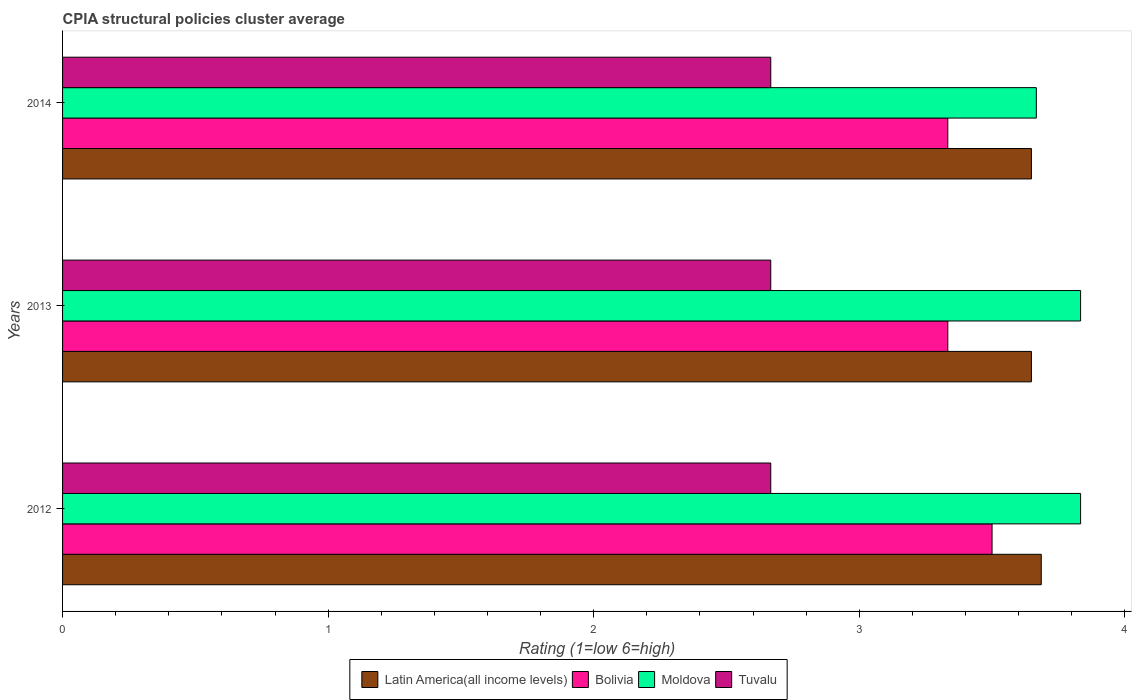How many different coloured bars are there?
Provide a short and direct response. 4. How many bars are there on the 3rd tick from the bottom?
Provide a succinct answer. 4. What is the label of the 2nd group of bars from the top?
Provide a succinct answer. 2013. In how many cases, is the number of bars for a given year not equal to the number of legend labels?
Your answer should be very brief. 0. What is the CPIA rating in Moldova in 2014?
Make the answer very short. 3.67. Across all years, what is the maximum CPIA rating in Moldova?
Make the answer very short. 3.83. Across all years, what is the minimum CPIA rating in Latin America(all income levels)?
Your answer should be very brief. 3.65. In which year was the CPIA rating in Latin America(all income levels) maximum?
Give a very brief answer. 2012. What is the total CPIA rating in Bolivia in the graph?
Ensure brevity in your answer.  10.17. What is the difference between the CPIA rating in Moldova in 2012 and that in 2014?
Provide a succinct answer. 0.17. What is the difference between the CPIA rating in Moldova in 2013 and the CPIA rating in Tuvalu in 2012?
Provide a succinct answer. 1.17. What is the average CPIA rating in Bolivia per year?
Make the answer very short. 3.39. In the year 2012, what is the difference between the CPIA rating in Tuvalu and CPIA rating in Bolivia?
Offer a very short reply. -0.83. In how many years, is the CPIA rating in Moldova greater than 2.6 ?
Offer a terse response. 3. What is the ratio of the CPIA rating in Moldova in 2013 to that in 2014?
Ensure brevity in your answer.  1.05. Is the CPIA rating in Bolivia in 2013 less than that in 2014?
Your answer should be compact. No. What is the difference between the highest and the lowest CPIA rating in Latin America(all income levels)?
Give a very brief answer. 0.04. In how many years, is the CPIA rating in Moldova greater than the average CPIA rating in Moldova taken over all years?
Your response must be concise. 2. Is it the case that in every year, the sum of the CPIA rating in Latin America(all income levels) and CPIA rating in Tuvalu is greater than the sum of CPIA rating in Moldova and CPIA rating in Bolivia?
Ensure brevity in your answer.  No. What does the 2nd bar from the top in 2014 represents?
Give a very brief answer. Moldova. What does the 2nd bar from the bottom in 2014 represents?
Keep it short and to the point. Bolivia. How many bars are there?
Offer a terse response. 12. Are all the bars in the graph horizontal?
Keep it short and to the point. Yes. How many years are there in the graph?
Provide a short and direct response. 3. What is the difference between two consecutive major ticks on the X-axis?
Give a very brief answer. 1. Are the values on the major ticks of X-axis written in scientific E-notation?
Provide a succinct answer. No. Where does the legend appear in the graph?
Your answer should be compact. Bottom center. How are the legend labels stacked?
Give a very brief answer. Horizontal. What is the title of the graph?
Make the answer very short. CPIA structural policies cluster average. What is the label or title of the Y-axis?
Provide a short and direct response. Years. What is the Rating (1=low 6=high) in Latin America(all income levels) in 2012?
Offer a terse response. 3.69. What is the Rating (1=low 6=high) in Moldova in 2012?
Your answer should be very brief. 3.83. What is the Rating (1=low 6=high) in Tuvalu in 2012?
Offer a terse response. 2.67. What is the Rating (1=low 6=high) in Latin America(all income levels) in 2013?
Your response must be concise. 3.65. What is the Rating (1=low 6=high) of Bolivia in 2013?
Offer a terse response. 3.33. What is the Rating (1=low 6=high) of Moldova in 2013?
Provide a short and direct response. 3.83. What is the Rating (1=low 6=high) in Tuvalu in 2013?
Keep it short and to the point. 2.67. What is the Rating (1=low 6=high) in Latin America(all income levels) in 2014?
Provide a succinct answer. 3.65. What is the Rating (1=low 6=high) in Bolivia in 2014?
Keep it short and to the point. 3.33. What is the Rating (1=low 6=high) of Moldova in 2014?
Your response must be concise. 3.67. What is the Rating (1=low 6=high) of Tuvalu in 2014?
Ensure brevity in your answer.  2.67. Across all years, what is the maximum Rating (1=low 6=high) in Latin America(all income levels)?
Provide a succinct answer. 3.69. Across all years, what is the maximum Rating (1=low 6=high) in Bolivia?
Give a very brief answer. 3.5. Across all years, what is the maximum Rating (1=low 6=high) of Moldova?
Keep it short and to the point. 3.83. Across all years, what is the maximum Rating (1=low 6=high) of Tuvalu?
Offer a very short reply. 2.67. Across all years, what is the minimum Rating (1=low 6=high) in Latin America(all income levels)?
Keep it short and to the point. 3.65. Across all years, what is the minimum Rating (1=low 6=high) in Bolivia?
Your answer should be compact. 3.33. Across all years, what is the minimum Rating (1=low 6=high) of Moldova?
Provide a succinct answer. 3.67. Across all years, what is the minimum Rating (1=low 6=high) of Tuvalu?
Ensure brevity in your answer.  2.67. What is the total Rating (1=low 6=high) in Latin America(all income levels) in the graph?
Keep it short and to the point. 10.98. What is the total Rating (1=low 6=high) in Bolivia in the graph?
Offer a terse response. 10.17. What is the total Rating (1=low 6=high) in Moldova in the graph?
Ensure brevity in your answer.  11.33. What is the total Rating (1=low 6=high) of Tuvalu in the graph?
Offer a very short reply. 8. What is the difference between the Rating (1=low 6=high) in Latin America(all income levels) in 2012 and that in 2013?
Provide a succinct answer. 0.04. What is the difference between the Rating (1=low 6=high) in Moldova in 2012 and that in 2013?
Your answer should be very brief. 0. What is the difference between the Rating (1=low 6=high) in Tuvalu in 2012 and that in 2013?
Ensure brevity in your answer.  0. What is the difference between the Rating (1=low 6=high) of Latin America(all income levels) in 2012 and that in 2014?
Offer a very short reply. 0.04. What is the difference between the Rating (1=low 6=high) in Bolivia in 2012 and that in 2014?
Provide a succinct answer. 0.17. What is the difference between the Rating (1=low 6=high) in Moldova in 2012 and that in 2014?
Offer a very short reply. 0.17. What is the difference between the Rating (1=low 6=high) of Tuvalu in 2012 and that in 2014?
Keep it short and to the point. -0. What is the difference between the Rating (1=low 6=high) of Tuvalu in 2013 and that in 2014?
Ensure brevity in your answer.  -0. What is the difference between the Rating (1=low 6=high) of Latin America(all income levels) in 2012 and the Rating (1=low 6=high) of Bolivia in 2013?
Keep it short and to the point. 0.35. What is the difference between the Rating (1=low 6=high) of Latin America(all income levels) in 2012 and the Rating (1=low 6=high) of Moldova in 2013?
Offer a very short reply. -0.15. What is the difference between the Rating (1=low 6=high) in Latin America(all income levels) in 2012 and the Rating (1=low 6=high) in Tuvalu in 2013?
Provide a short and direct response. 1.02. What is the difference between the Rating (1=low 6=high) of Bolivia in 2012 and the Rating (1=low 6=high) of Tuvalu in 2013?
Ensure brevity in your answer.  0.83. What is the difference between the Rating (1=low 6=high) of Latin America(all income levels) in 2012 and the Rating (1=low 6=high) of Bolivia in 2014?
Ensure brevity in your answer.  0.35. What is the difference between the Rating (1=low 6=high) of Latin America(all income levels) in 2012 and the Rating (1=low 6=high) of Moldova in 2014?
Ensure brevity in your answer.  0.02. What is the difference between the Rating (1=low 6=high) of Latin America(all income levels) in 2012 and the Rating (1=low 6=high) of Tuvalu in 2014?
Provide a succinct answer. 1.02. What is the difference between the Rating (1=low 6=high) of Moldova in 2012 and the Rating (1=low 6=high) of Tuvalu in 2014?
Provide a short and direct response. 1.17. What is the difference between the Rating (1=low 6=high) in Latin America(all income levels) in 2013 and the Rating (1=low 6=high) in Bolivia in 2014?
Make the answer very short. 0.31. What is the difference between the Rating (1=low 6=high) of Latin America(all income levels) in 2013 and the Rating (1=low 6=high) of Moldova in 2014?
Offer a terse response. -0.02. What is the difference between the Rating (1=low 6=high) in Latin America(all income levels) in 2013 and the Rating (1=low 6=high) in Tuvalu in 2014?
Your response must be concise. 0.98. What is the average Rating (1=low 6=high) in Latin America(all income levels) per year?
Provide a short and direct response. 3.66. What is the average Rating (1=low 6=high) of Bolivia per year?
Make the answer very short. 3.39. What is the average Rating (1=low 6=high) of Moldova per year?
Ensure brevity in your answer.  3.78. What is the average Rating (1=low 6=high) in Tuvalu per year?
Your answer should be compact. 2.67. In the year 2012, what is the difference between the Rating (1=low 6=high) in Latin America(all income levels) and Rating (1=low 6=high) in Bolivia?
Make the answer very short. 0.19. In the year 2012, what is the difference between the Rating (1=low 6=high) in Latin America(all income levels) and Rating (1=low 6=high) in Moldova?
Ensure brevity in your answer.  -0.15. In the year 2012, what is the difference between the Rating (1=low 6=high) of Latin America(all income levels) and Rating (1=low 6=high) of Tuvalu?
Offer a terse response. 1.02. In the year 2012, what is the difference between the Rating (1=low 6=high) of Bolivia and Rating (1=low 6=high) of Moldova?
Make the answer very short. -0.33. In the year 2012, what is the difference between the Rating (1=low 6=high) in Moldova and Rating (1=low 6=high) in Tuvalu?
Offer a very short reply. 1.17. In the year 2013, what is the difference between the Rating (1=low 6=high) of Latin America(all income levels) and Rating (1=low 6=high) of Bolivia?
Make the answer very short. 0.31. In the year 2013, what is the difference between the Rating (1=low 6=high) in Latin America(all income levels) and Rating (1=low 6=high) in Moldova?
Make the answer very short. -0.19. In the year 2013, what is the difference between the Rating (1=low 6=high) of Latin America(all income levels) and Rating (1=low 6=high) of Tuvalu?
Give a very brief answer. 0.98. In the year 2014, what is the difference between the Rating (1=low 6=high) in Latin America(all income levels) and Rating (1=low 6=high) in Bolivia?
Your answer should be compact. 0.31. In the year 2014, what is the difference between the Rating (1=low 6=high) of Latin America(all income levels) and Rating (1=low 6=high) of Moldova?
Your answer should be very brief. -0.02. In the year 2014, what is the difference between the Rating (1=low 6=high) in Latin America(all income levels) and Rating (1=low 6=high) in Tuvalu?
Offer a terse response. 0.98. What is the ratio of the Rating (1=low 6=high) in Latin America(all income levels) in 2012 to that in 2013?
Make the answer very short. 1.01. What is the ratio of the Rating (1=low 6=high) in Bolivia in 2012 to that in 2013?
Offer a very short reply. 1.05. What is the ratio of the Rating (1=low 6=high) of Latin America(all income levels) in 2012 to that in 2014?
Your response must be concise. 1.01. What is the ratio of the Rating (1=low 6=high) in Moldova in 2012 to that in 2014?
Give a very brief answer. 1.05. What is the ratio of the Rating (1=low 6=high) of Moldova in 2013 to that in 2014?
Your response must be concise. 1.05. What is the ratio of the Rating (1=low 6=high) in Tuvalu in 2013 to that in 2014?
Offer a very short reply. 1. What is the difference between the highest and the second highest Rating (1=low 6=high) in Latin America(all income levels)?
Your response must be concise. 0.04. What is the difference between the highest and the lowest Rating (1=low 6=high) of Latin America(all income levels)?
Provide a short and direct response. 0.04. What is the difference between the highest and the lowest Rating (1=low 6=high) in Bolivia?
Keep it short and to the point. 0.17. 